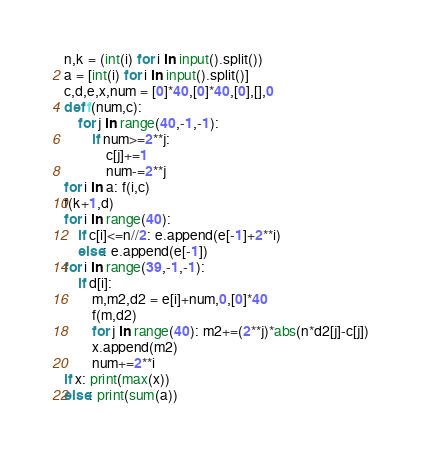Convert code to text. <code><loc_0><loc_0><loc_500><loc_500><_Python_>n,k = (int(i) for i in input().split())
a = [int(i) for i in input().split()]
c,d,e,x,num = [0]*40,[0]*40,[0],[],0
def f(num,c):
    for j in range(40,-1,-1):
        if num>=2**j:
            c[j]+=1
            num-=2**j
for i in a: f(i,c)
f(k+1,d)
for i in range(40):
    if c[i]<=n//2: e.append(e[-1]+2**i)
    else: e.append(e[-1])
for i in range(39,-1,-1):
    if d[i]:
        m,m2,d2 = e[i]+num,0,[0]*40
        f(m,d2)
        for j in range(40): m2+=(2**j)*abs(n*d2[j]-c[j])
        x.append(m2)
        num+=2**i
if x: print(max(x))
else: print(sum(a))</code> 